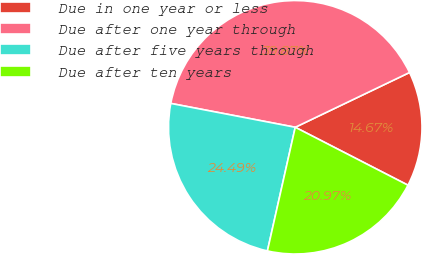Convert chart to OTSL. <chart><loc_0><loc_0><loc_500><loc_500><pie_chart><fcel>Due in one year or less<fcel>Due after one year through<fcel>Due after five years through<fcel>Due after ten years<nl><fcel>14.67%<fcel>39.87%<fcel>24.49%<fcel>20.97%<nl></chart> 